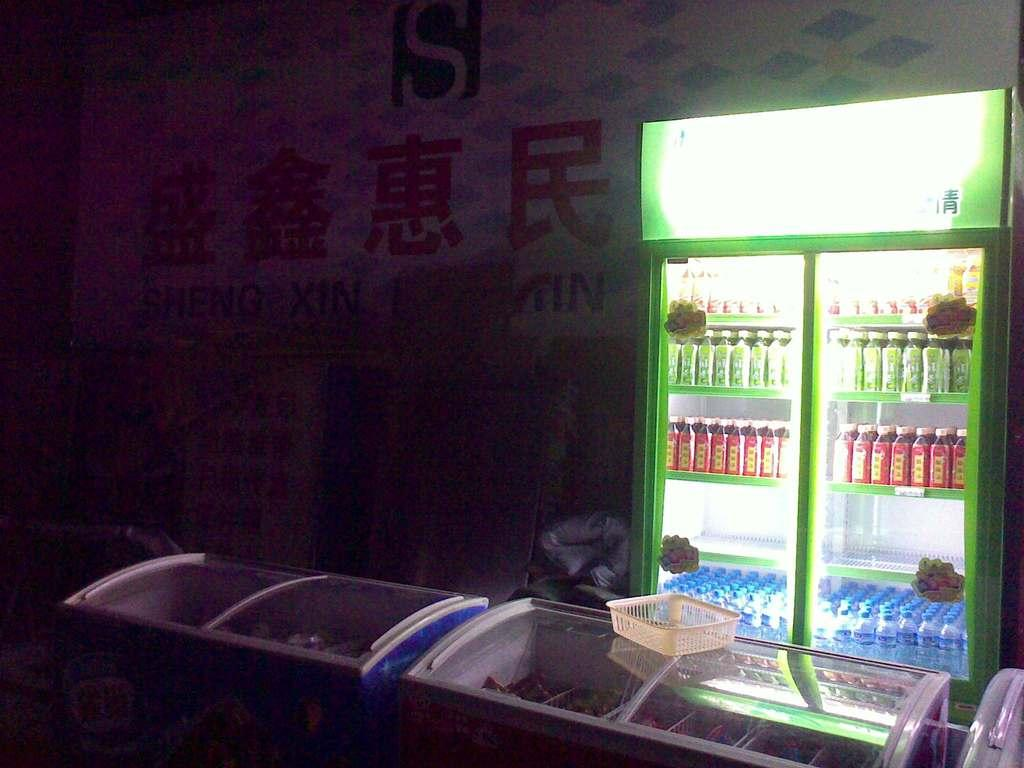<image>
Create a compact narrative representing the image presented. Fridge inside of a store seling soda and a letter S next to it. 